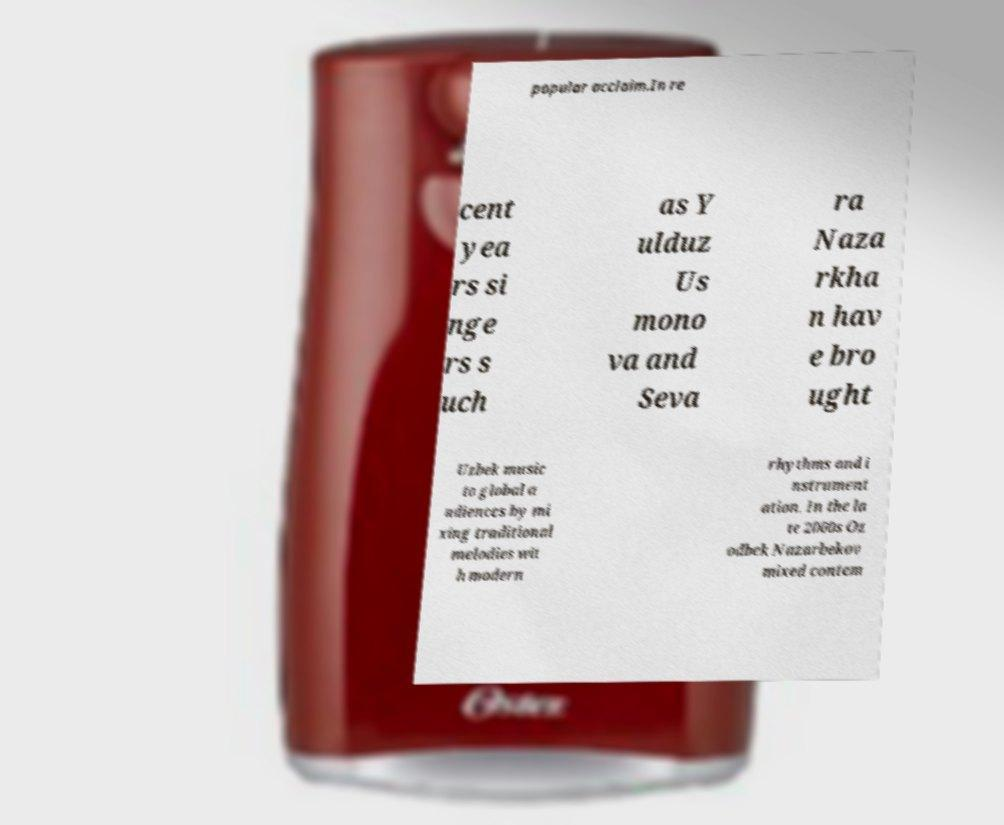Could you assist in decoding the text presented in this image and type it out clearly? popular acclaim.In re cent yea rs si nge rs s uch as Y ulduz Us mono va and Seva ra Naza rkha n hav e bro ught Uzbek music to global a udiences by mi xing traditional melodies wit h modern rhythms and i nstrument ation. In the la te 2000s Oz odbek Nazarbekov mixed contem 